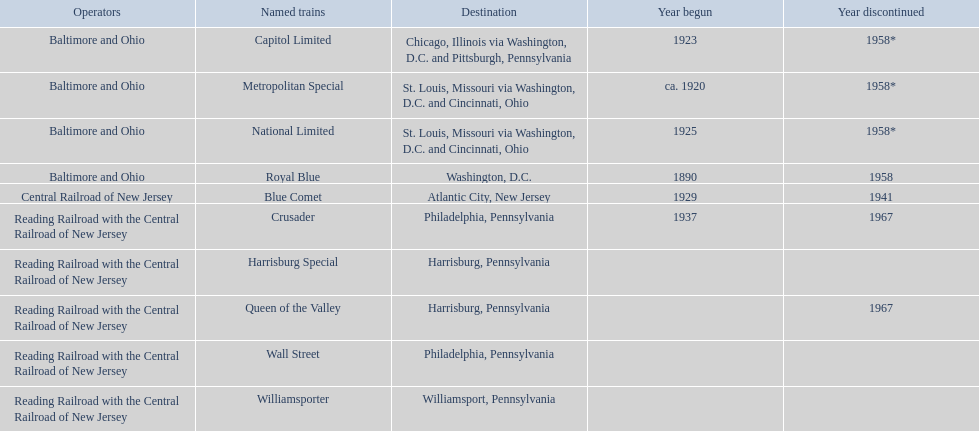Which of the trains are operated by reading railroad with the central railroad of new jersey? Crusader, Harrisburg Special, Queen of the Valley, Wall Street, Williamsporter. Of these trains, which of them had a destination of philadelphia, pennsylvania? Crusader, Wall Street. Out of these two trains, which one is discontinued? Crusader. 